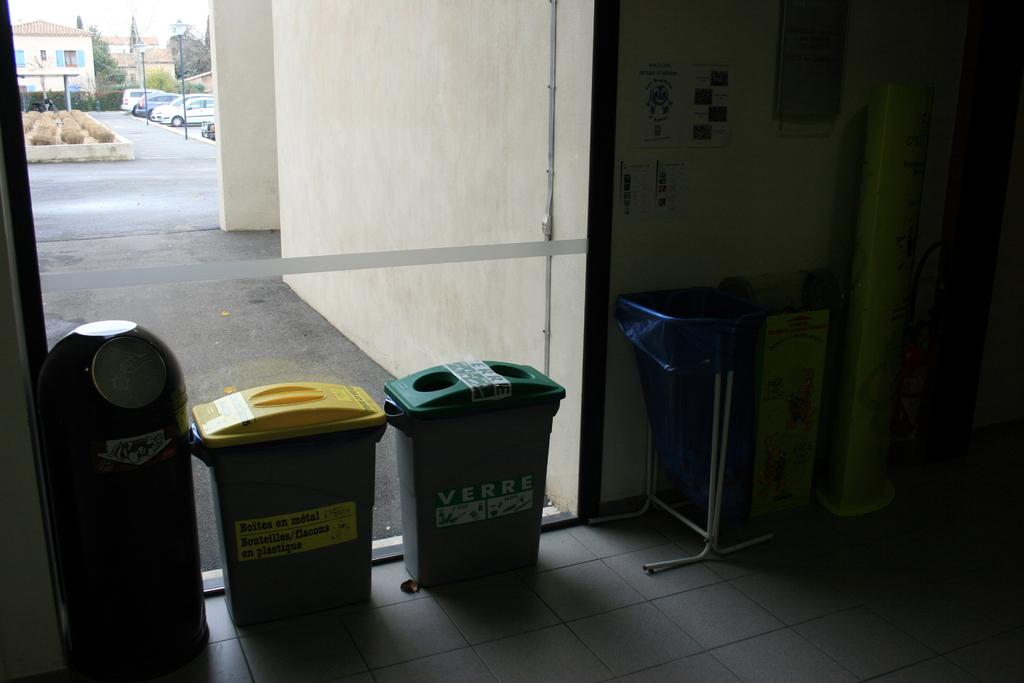What is written on the bins?
Keep it short and to the point. Verre. 